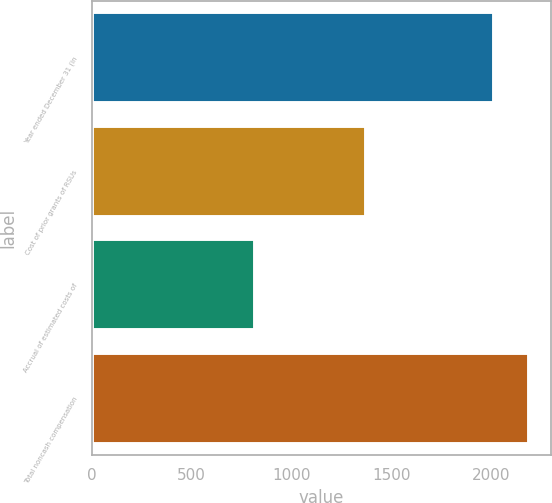Convert chart. <chart><loc_0><loc_0><loc_500><loc_500><bar_chart><fcel>Year ended December 31 (in<fcel>Cost of prior grants of RSUs<fcel>Accrual of estimated costs of<fcel>Total noncash compensation<nl><fcel>2014<fcel>1371<fcel>819<fcel>2190<nl></chart> 